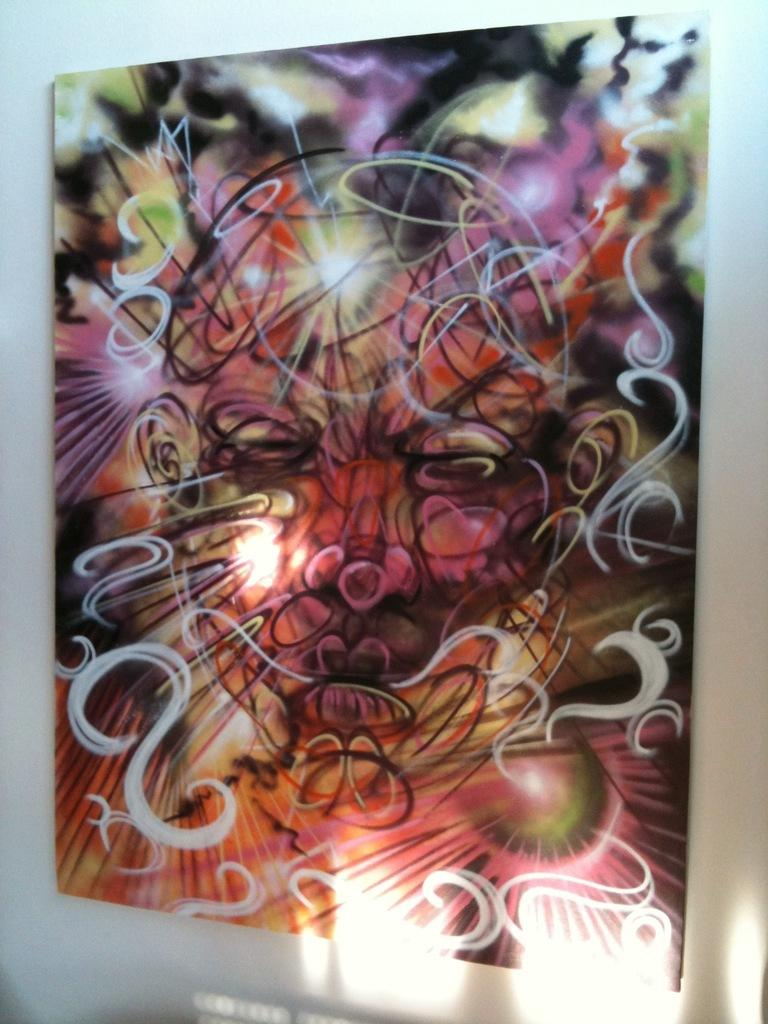What type of artwork is featured in the image? There is an abstract painting in the image. How is the painting displayed? The painting is on a board. Where is the board with the painting located? The board is on a wall. How many jars of jam are on the wall next to the painting? There is no mention of jars of jam in the image; the image only features an abstract painting on a board that is on a wall. 